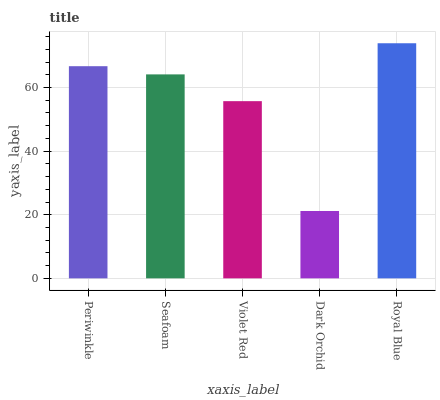Is Dark Orchid the minimum?
Answer yes or no. Yes. Is Royal Blue the maximum?
Answer yes or no. Yes. Is Seafoam the minimum?
Answer yes or no. No. Is Seafoam the maximum?
Answer yes or no. No. Is Periwinkle greater than Seafoam?
Answer yes or no. Yes. Is Seafoam less than Periwinkle?
Answer yes or no. Yes. Is Seafoam greater than Periwinkle?
Answer yes or no. No. Is Periwinkle less than Seafoam?
Answer yes or no. No. Is Seafoam the high median?
Answer yes or no. Yes. Is Seafoam the low median?
Answer yes or no. Yes. Is Royal Blue the high median?
Answer yes or no. No. Is Periwinkle the low median?
Answer yes or no. No. 